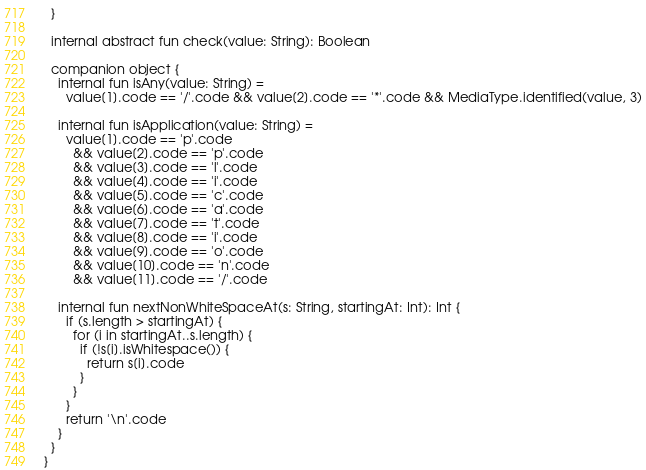<code> <loc_0><loc_0><loc_500><loc_500><_Kotlin_>  }

  internal abstract fun check(value: String): Boolean

  companion object {
    internal fun isAny(value: String) =
      value[1].code == '/'.code && value[2].code == '*'.code && MediaType.identified(value, 3)

    internal fun isApplication(value: String) =
      value[1].code == 'p'.code
        && value[2].code == 'p'.code
        && value[3].code == 'l'.code
        && value[4].code == 'i'.code
        && value[5].code == 'c'.code
        && value[6].code == 'a'.code
        && value[7].code == 't'.code
        && value[8].code == 'i'.code
        && value[9].code == 'o'.code
        && value[10].code == 'n'.code
        && value[11].code == '/'.code

    internal fun nextNonWhiteSpaceAt(s: String, startingAt: Int): Int {
      if (s.length > startingAt) {
        for (i in startingAt..s.length) {
          if (!s[i].isWhitespace()) {
            return s[i].code
          }
        }
      }
      return '\n'.code
    }
  }
}
</code> 